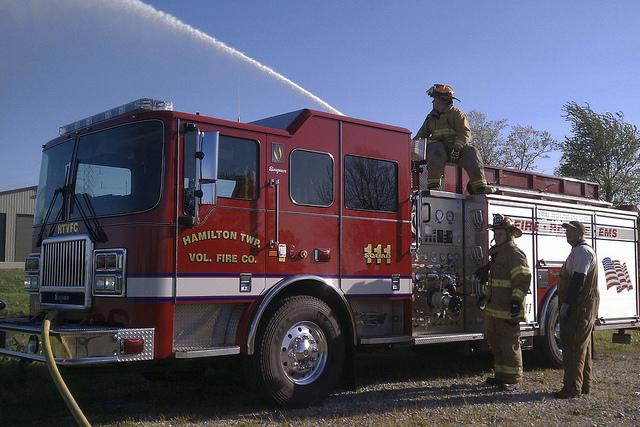What province does this fire crew reside in? Please explain your reasoning. ontario. The town of hamilton is in a city of ontario. 